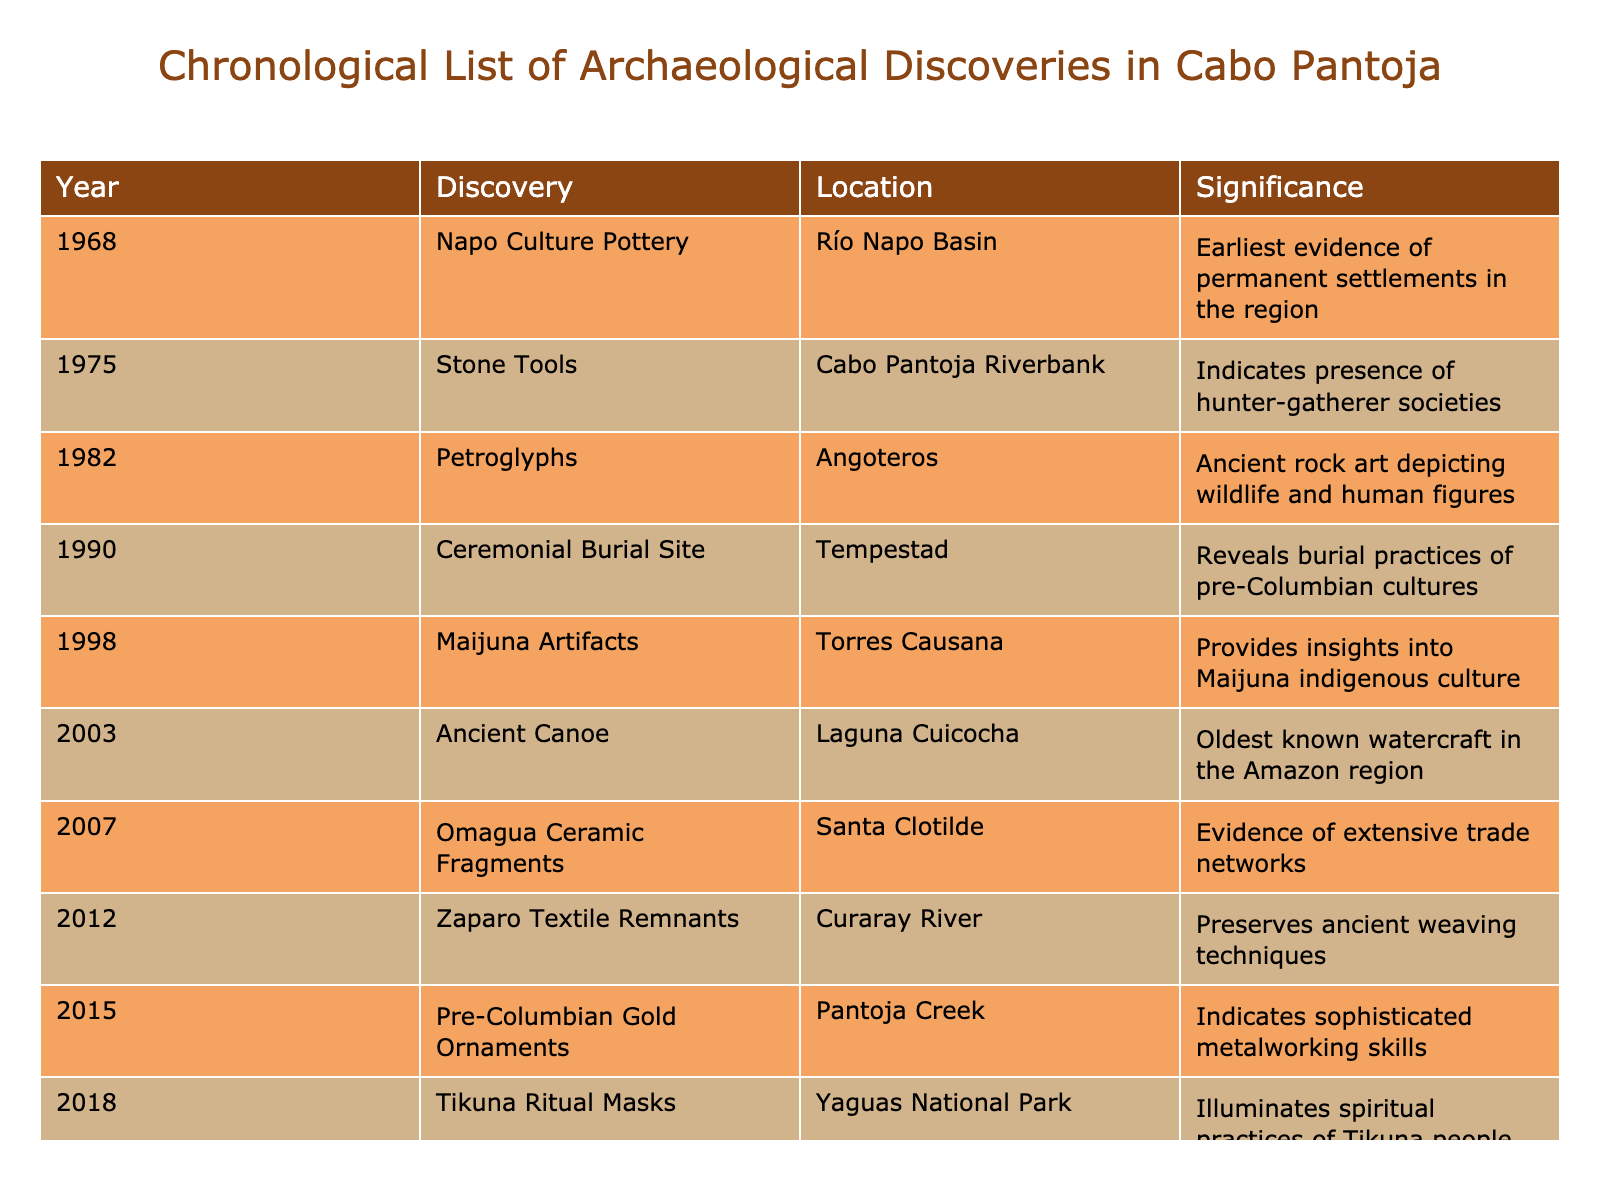What archaeological discovery occurred in 1982? The table lists the discoveries chronologically, and the entry for 1982 shows "Petroglyphs" as the significant discovery.
Answer: Petroglyphs Which location has evidence of extensive trade networks? According to the table, "Omagua Ceramic Fragments" discovered in "Santa Clotilde" provides evidence of extensive trade networks.
Answer: Santa Clotilde What is the significance of the discovery made in 2015? The table states that the "Pre-Columbian Gold Ornaments" found in "Pantoja Creek" indicate sophisticated metalworking skills of the cultures at that time.
Answer: Indicates sophisticated metalworking skills How many discoveries are listed before the year 2000? By counting the entries from the table, there are 7 discoveries from 1968 to 1998, which includes the years before 2000.
Answer: 7 True or False: The oldest known watercraft in the Amazon was discovered in the Cabo Pantoja region. The table indicates that the "Ancient Canoe," identified as the oldest known watercraft in the Amazon region, was discovered in "Laguna Cuicocha." This confirms the statement as true.
Answer: True What are the two most recent discoveries listed in the table, and what are their significance? The last two entries in the table are from 2018 and 2021, which are "Tikuna Ritual Masks" significant for illuminating spiritual practices of the Tikuna people, and "Ancient Seed Cache," which reveals early agricultural practices.
Answer: Tikuna Ritual Masks; Ancient Seed Cache Which discovery indicates early agricultural practices? From the table, the entry for "Ancient Seed Cache" discovered in "Güeppí-Sekime National Park" is specifically notable for revealing early agricultural practices.
Answer: Ancient Seed Cache What year marks the discovery of artifacts relating to the Maijuna indigenous culture? The discovery related to the Maijuna culture occurred in 1998, as stated in the table.
Answer: 1998 What do the discoveries from 2003 and 2007 have in common? Both discoveries, "Ancient Canoe" in 2003 and "Omagua Ceramic Fragments" in 2007, provide evidence related to trade and cultural practices in the region. They both reflect the complexity of societal interactions.
Answer: Both relate to trade and cultural practices What is the difference in years between the discovery of the Maijuna artifacts and the ceremonial burial site? The Maijuna artifacts were discovered in 1998, and the ceremonial burial site was found in 1990. The difference is 8 years from 1990 to 1998.
Answer: 8 years Which significant archaeological discovery happened the earliest and what was its significance? The earliest discovery, "Napo Culture Pottery," occurred in 1968, indicating the earliest evidence of permanent settlements in the region, as per the table.
Answer: Napo Culture Pottery; evidence of permanent settlements 